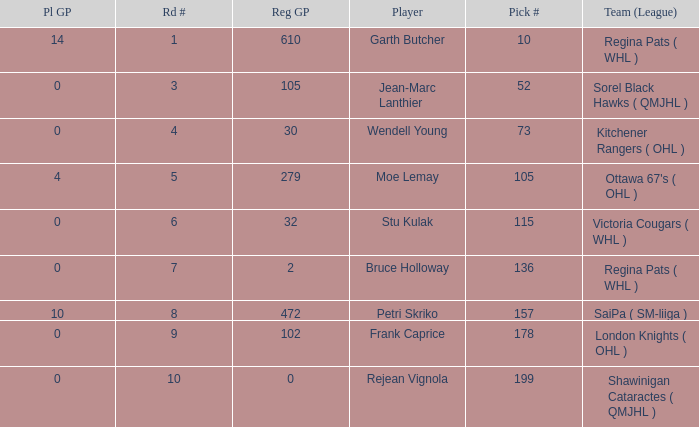What is the total number of Pl GP when the pick number is 199 and the Reg GP is bigger than 0? None. 